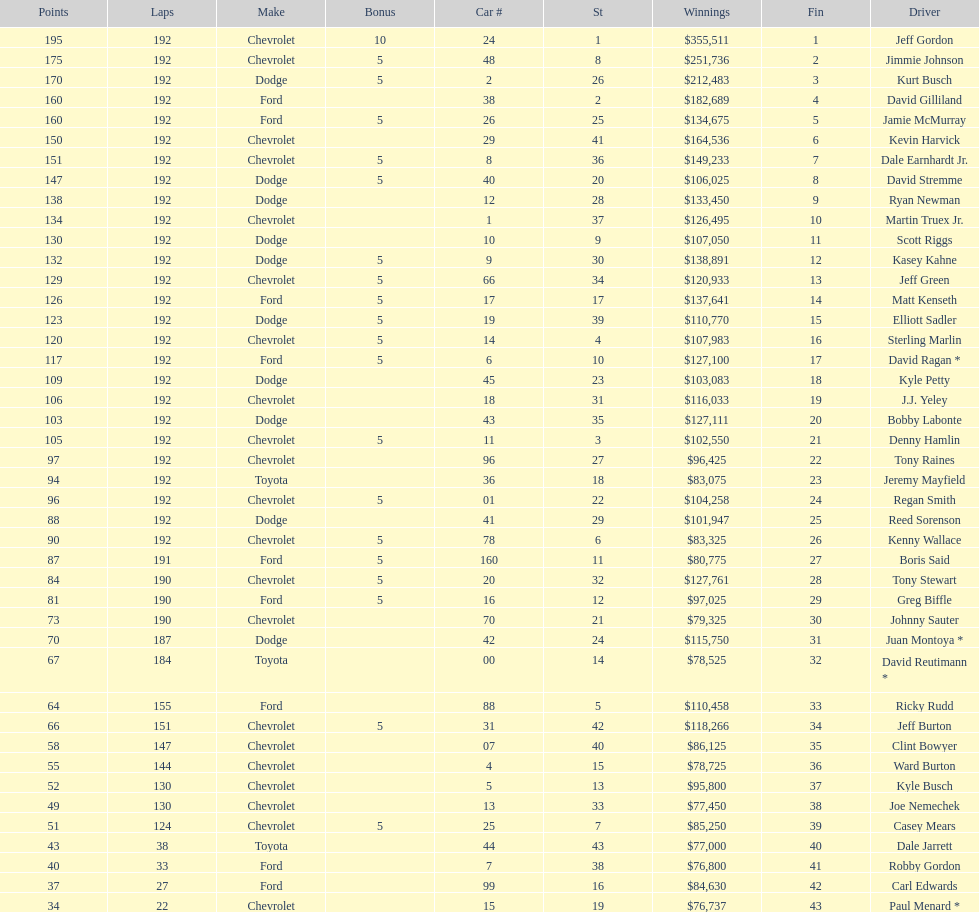How many drivers placed below tony stewart? 15. 